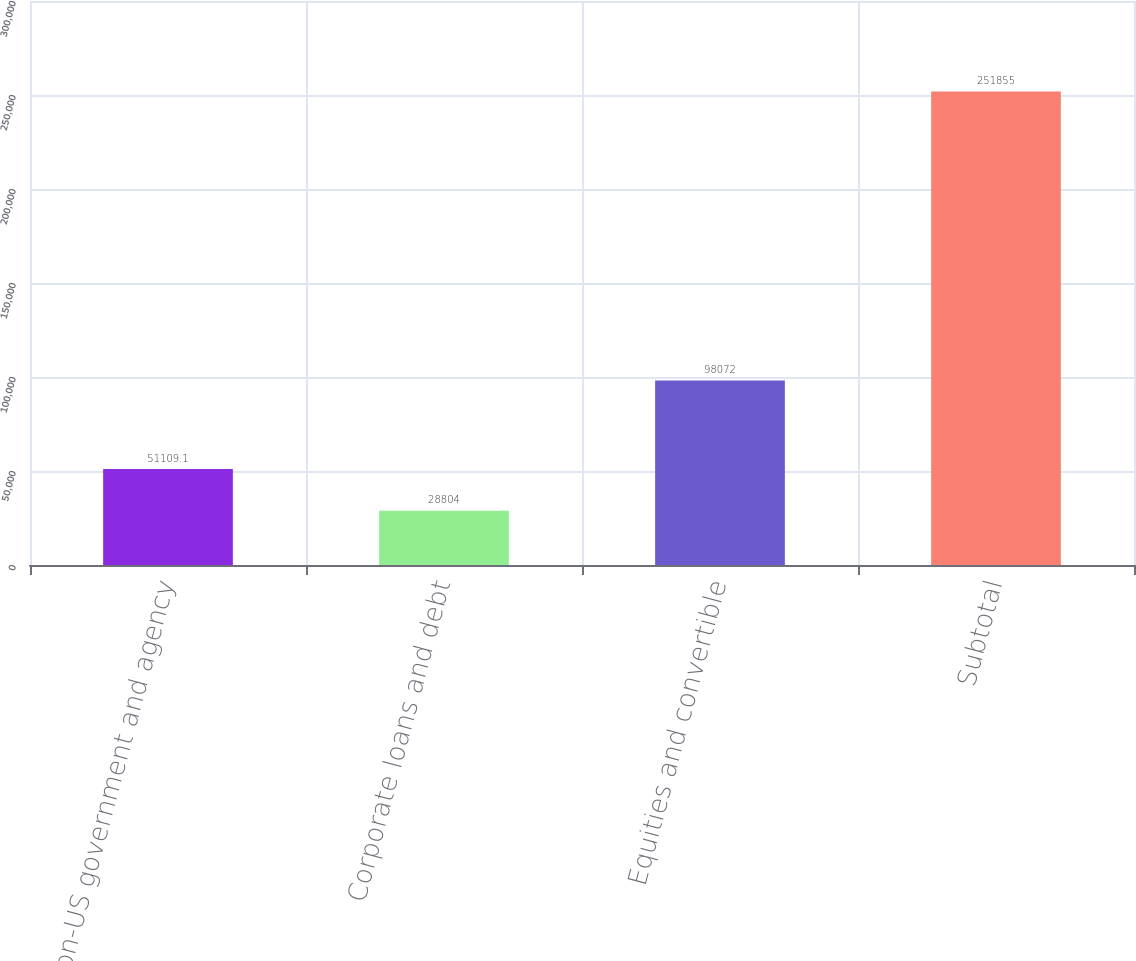<chart> <loc_0><loc_0><loc_500><loc_500><bar_chart><fcel>Non-US government and agency<fcel>Corporate loans and debt<fcel>Equities and convertible<fcel>Subtotal<nl><fcel>51109.1<fcel>28804<fcel>98072<fcel>251855<nl></chart> 